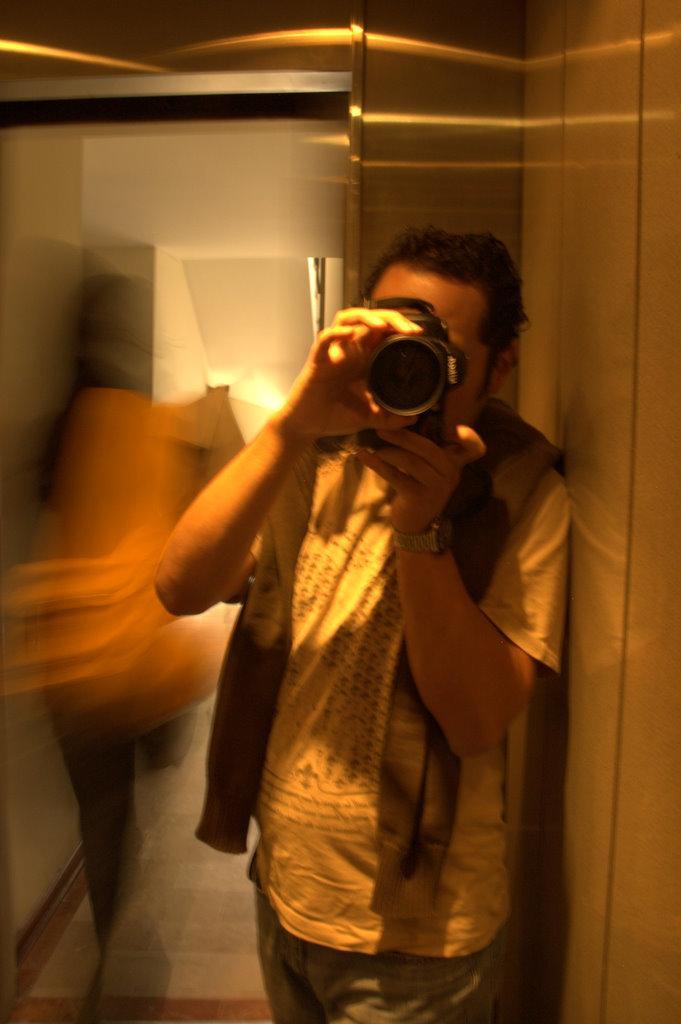Please provide a concise description of this image. In the right there is a man he wear watch , t shirt ,trouser ,in his hand he holding a camera ,i think he is clicking some photos. On the left there is a person. In the background there is a light ,wall. 